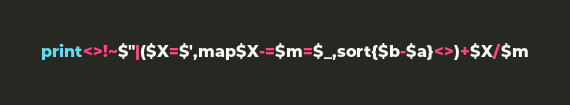<code> <loc_0><loc_0><loc_500><loc_500><_Perl_>print<>!~$"|($X=$',map$X-=$m=$_,sort{$b-$a}<>)+$X/$m</code> 